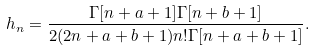<formula> <loc_0><loc_0><loc_500><loc_500>h _ { n } = \frac { \Gamma [ n + a + 1 ] \Gamma [ n + b + 1 ] } { 2 ( 2 n + a + b + 1 ) n ! \Gamma [ n + a + b + 1 ] } .</formula> 